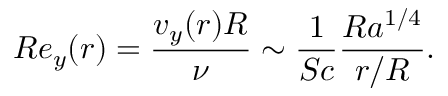Convert formula to latex. <formula><loc_0><loc_0><loc_500><loc_500>R e _ { y } ( r ) = \frac { v _ { y } ( r ) R } { \nu } \sim \frac { 1 } { S c } \frac { R a ^ { 1 / 4 } } { r / R } .</formula> 